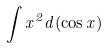Convert formula to latex. <formula><loc_0><loc_0><loc_500><loc_500>\int x ^ { 2 } d ( \cos x )</formula> 